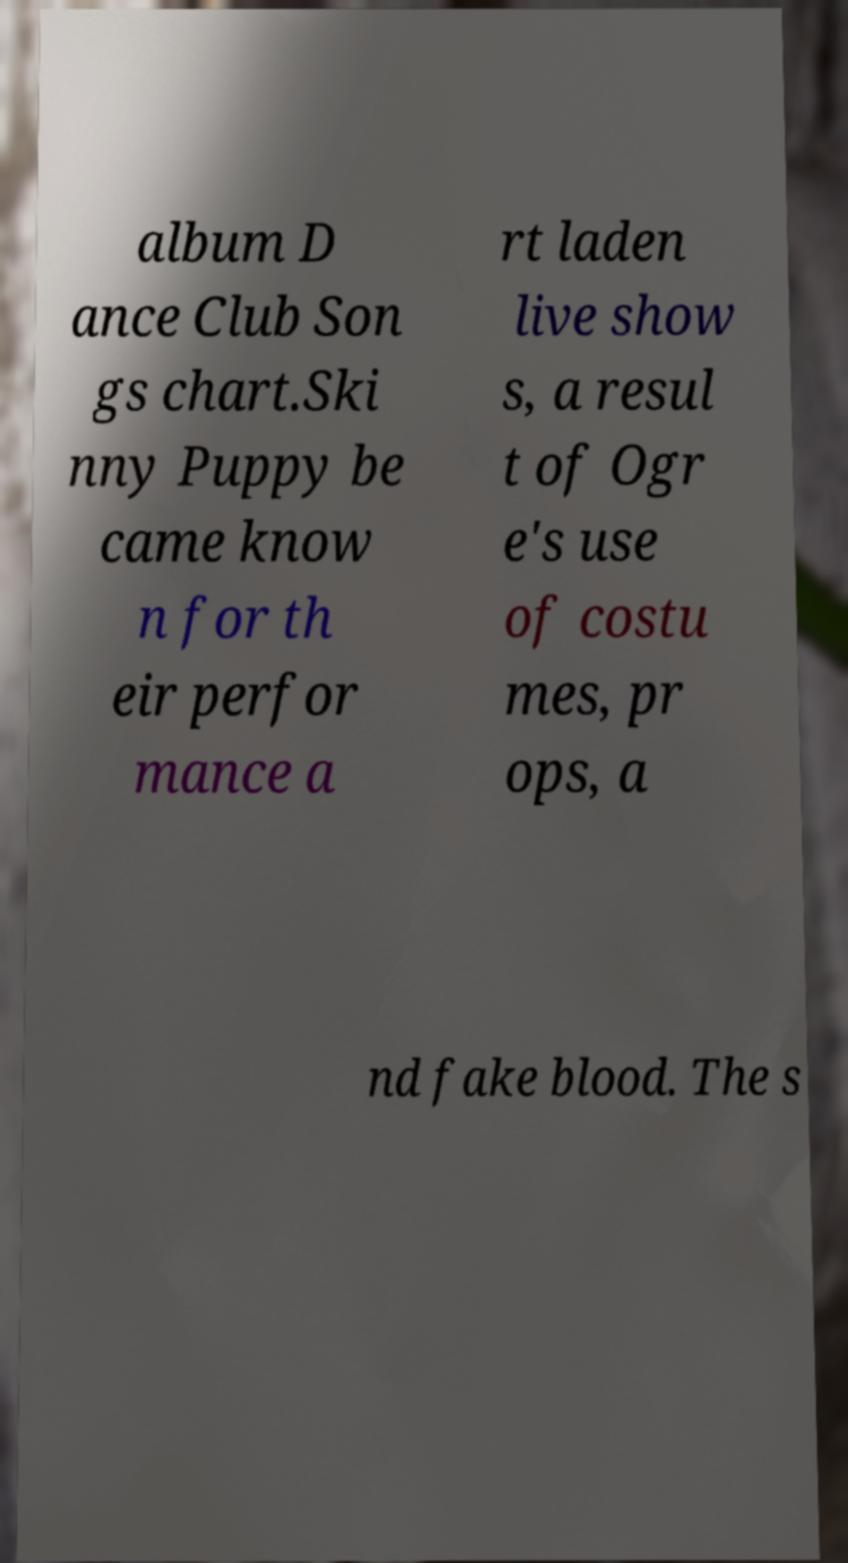Can you read and provide the text displayed in the image?This photo seems to have some interesting text. Can you extract and type it out for me? album D ance Club Son gs chart.Ski nny Puppy be came know n for th eir perfor mance a rt laden live show s, a resul t of Ogr e's use of costu mes, pr ops, a nd fake blood. The s 